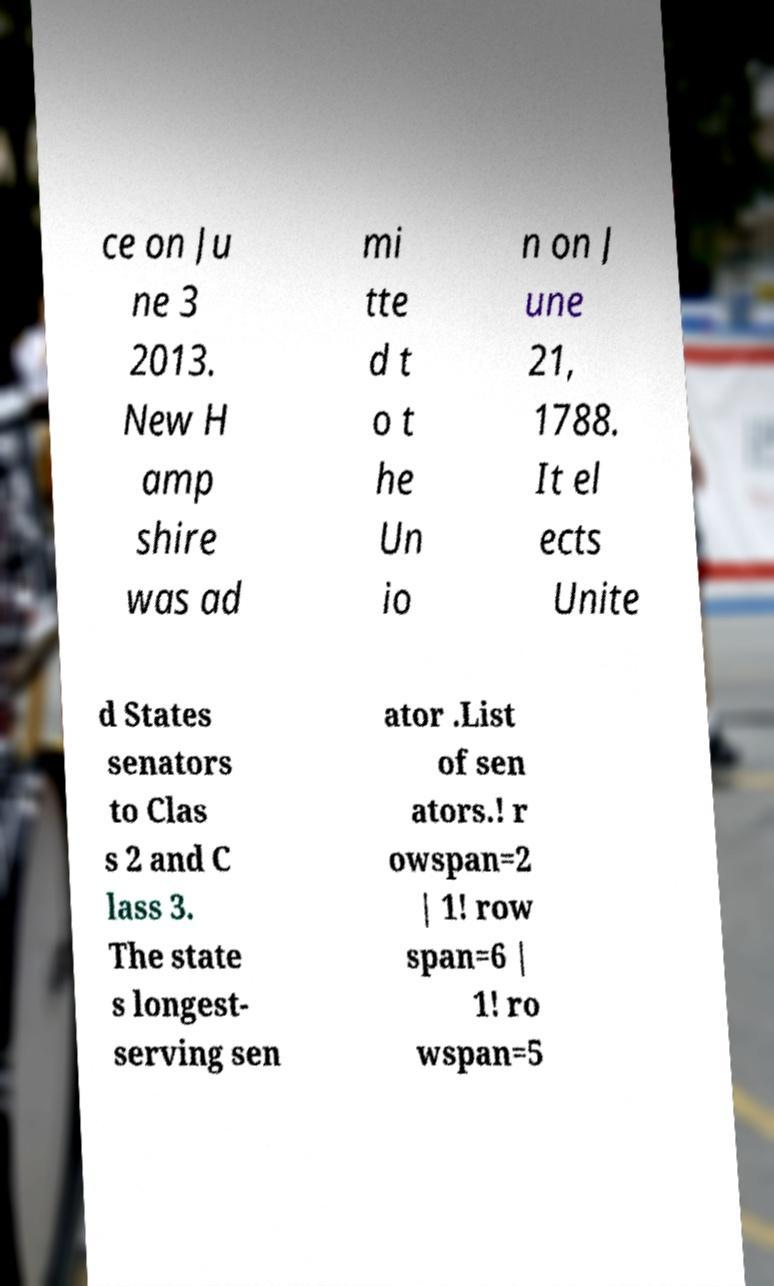Please read and relay the text visible in this image. What does it say? ce on Ju ne 3 2013. New H amp shire was ad mi tte d t o t he Un io n on J une 21, 1788. It el ects Unite d States senators to Clas s 2 and C lass 3. The state s longest- serving sen ator .List of sen ators.! r owspan=2 | 1! row span=6 | 1! ro wspan=5 